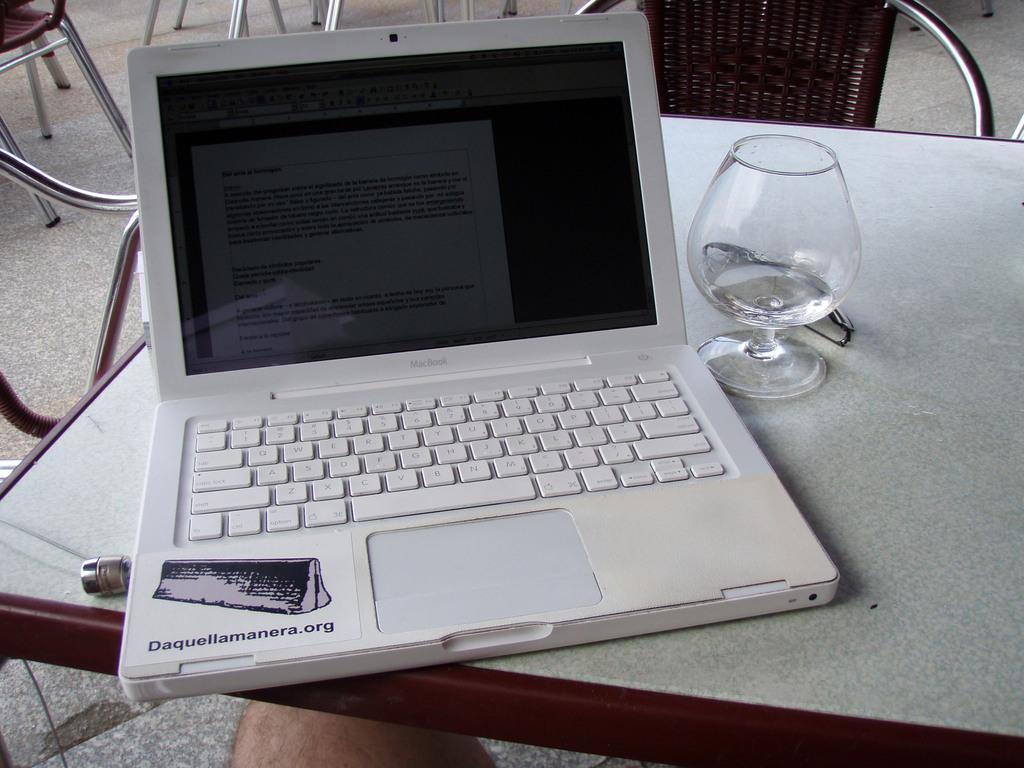Can you describe this image briefly? In this image, There is a table which is in white color, on that table there is a laptop in white color and there is a glass on the table, In the background there is a chair in brown color. 